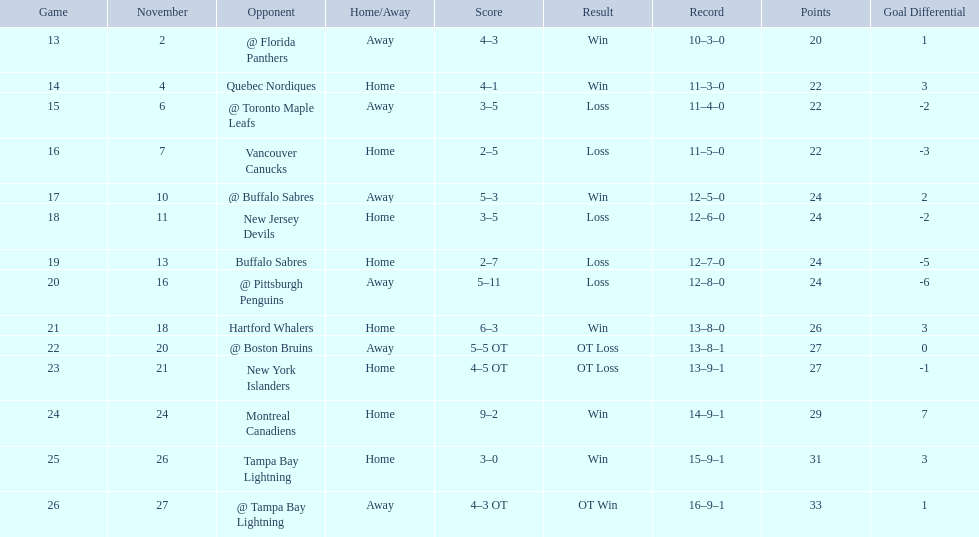What were the scores of the 1993-94 philadelphia flyers season? 4–3, 4–1, 3–5, 2–5, 5–3, 3–5, 2–7, 5–11, 6–3, 5–5 OT, 4–5 OT, 9–2, 3–0, 4–3 OT. Which of these teams had the score 4-5 ot? New York Islanders. 